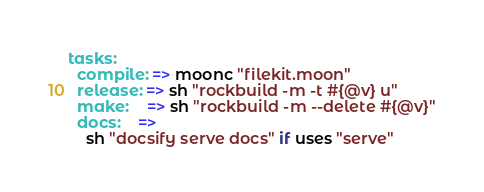<code> <loc_0><loc_0><loc_500><loc_500><_MoonScript_>tasks:
  compile: => moonc "filekit.moon"
  release: => sh "rockbuild -m -t #{@v} u"
  make:    => sh "rockbuild -m --delete #{@v}"
  docs:    =>
    sh "docsify serve docs" if uses "serve"</code> 